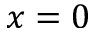Convert formula to latex. <formula><loc_0><loc_0><loc_500><loc_500>x = 0</formula> 